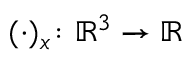<formula> <loc_0><loc_0><loc_500><loc_500>( \cdot ) _ { x } \colon { \mathbb { R } ^ { 3 } } \to \mathbb { R }</formula> 